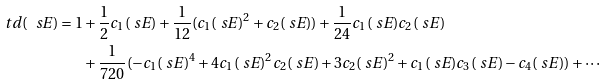Convert formula to latex. <formula><loc_0><loc_0><loc_500><loc_500>\ t d ( \ s E ) = 1 & + \frac { 1 } { 2 } c _ { 1 } ( \ s E ) + \frac { 1 } { 1 2 } ( c _ { 1 } ( \ s E ) ^ { 2 } + c _ { 2 } ( \ s E ) ) + \frac { 1 } { 2 4 } c _ { 1 } ( \ s E ) c _ { 2 } ( \ s E ) \\ & + \frac { 1 } { 7 2 0 } ( - c _ { 1 } ( \ s E ) ^ { 4 } + 4 c _ { 1 } ( \ s E ) ^ { 2 } c _ { 2 } ( \ s E ) + 3 c _ { 2 } ( \ s E ) ^ { 2 } + c _ { 1 } ( \ s E ) c _ { 3 } ( \ s E ) - c _ { 4 } ( \ s E ) ) + \cdots</formula> 